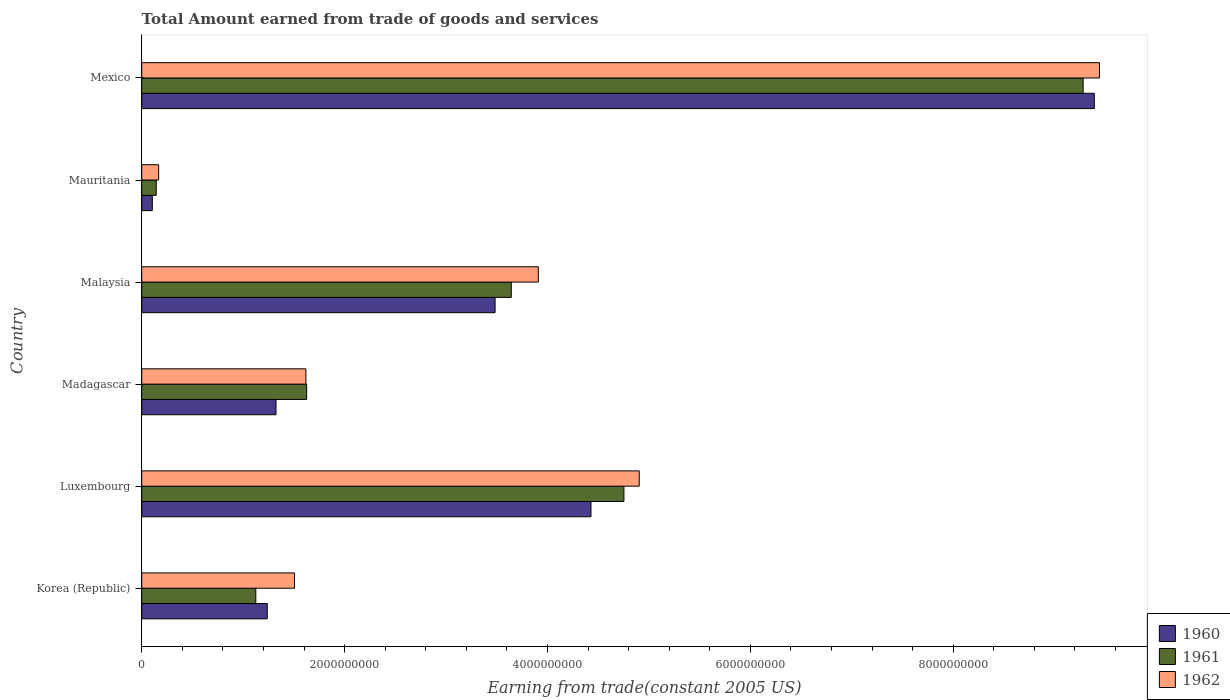Are the number of bars per tick equal to the number of legend labels?
Provide a short and direct response. Yes. How many bars are there on the 2nd tick from the bottom?
Make the answer very short. 3. What is the label of the 4th group of bars from the top?
Provide a succinct answer. Madagascar. What is the total amount earned by trading goods and services in 1962 in Malaysia?
Provide a succinct answer. 3.91e+09. Across all countries, what is the maximum total amount earned by trading goods and services in 1962?
Ensure brevity in your answer.  9.44e+09. Across all countries, what is the minimum total amount earned by trading goods and services in 1960?
Your answer should be very brief. 1.04e+08. In which country was the total amount earned by trading goods and services in 1961 maximum?
Offer a terse response. Mexico. In which country was the total amount earned by trading goods and services in 1960 minimum?
Make the answer very short. Mauritania. What is the total total amount earned by trading goods and services in 1960 in the graph?
Your answer should be compact. 2.00e+1. What is the difference between the total amount earned by trading goods and services in 1961 in Malaysia and that in Mexico?
Give a very brief answer. -5.64e+09. What is the difference between the total amount earned by trading goods and services in 1961 in Madagascar and the total amount earned by trading goods and services in 1962 in Korea (Republic)?
Your answer should be very brief. 1.20e+08. What is the average total amount earned by trading goods and services in 1962 per country?
Your response must be concise. 3.59e+09. What is the difference between the total amount earned by trading goods and services in 1961 and total amount earned by trading goods and services in 1962 in Madagascar?
Keep it short and to the point. 7.38e+06. What is the ratio of the total amount earned by trading goods and services in 1962 in Madagascar to that in Mauritania?
Make the answer very short. 9.69. Is the total amount earned by trading goods and services in 1962 in Korea (Republic) less than that in Madagascar?
Ensure brevity in your answer.  Yes. What is the difference between the highest and the second highest total amount earned by trading goods and services in 1962?
Make the answer very short. 4.54e+09. What is the difference between the highest and the lowest total amount earned by trading goods and services in 1960?
Your response must be concise. 9.29e+09. In how many countries, is the total amount earned by trading goods and services in 1962 greater than the average total amount earned by trading goods and services in 1962 taken over all countries?
Make the answer very short. 3. Is the sum of the total amount earned by trading goods and services in 1961 in Luxembourg and Madagascar greater than the maximum total amount earned by trading goods and services in 1962 across all countries?
Your answer should be compact. No. What does the 3rd bar from the bottom in Malaysia represents?
Ensure brevity in your answer.  1962. Is it the case that in every country, the sum of the total amount earned by trading goods and services in 1962 and total amount earned by trading goods and services in 1961 is greater than the total amount earned by trading goods and services in 1960?
Your response must be concise. Yes. Are all the bars in the graph horizontal?
Keep it short and to the point. Yes. How many countries are there in the graph?
Provide a short and direct response. 6. Are the values on the major ticks of X-axis written in scientific E-notation?
Offer a terse response. No. What is the title of the graph?
Keep it short and to the point. Total Amount earned from trade of goods and services. What is the label or title of the X-axis?
Offer a very short reply. Earning from trade(constant 2005 US). What is the label or title of the Y-axis?
Your response must be concise. Country. What is the Earning from trade(constant 2005 US) in 1960 in Korea (Republic)?
Offer a terse response. 1.24e+09. What is the Earning from trade(constant 2005 US) in 1961 in Korea (Republic)?
Give a very brief answer. 1.12e+09. What is the Earning from trade(constant 2005 US) of 1962 in Korea (Republic)?
Provide a short and direct response. 1.51e+09. What is the Earning from trade(constant 2005 US) of 1960 in Luxembourg?
Keep it short and to the point. 4.43e+09. What is the Earning from trade(constant 2005 US) in 1961 in Luxembourg?
Offer a very short reply. 4.75e+09. What is the Earning from trade(constant 2005 US) of 1962 in Luxembourg?
Provide a short and direct response. 4.90e+09. What is the Earning from trade(constant 2005 US) in 1960 in Madagascar?
Ensure brevity in your answer.  1.32e+09. What is the Earning from trade(constant 2005 US) in 1961 in Madagascar?
Keep it short and to the point. 1.63e+09. What is the Earning from trade(constant 2005 US) of 1962 in Madagascar?
Provide a succinct answer. 1.62e+09. What is the Earning from trade(constant 2005 US) of 1960 in Malaysia?
Offer a terse response. 3.48e+09. What is the Earning from trade(constant 2005 US) in 1961 in Malaysia?
Provide a succinct answer. 3.64e+09. What is the Earning from trade(constant 2005 US) of 1962 in Malaysia?
Your response must be concise. 3.91e+09. What is the Earning from trade(constant 2005 US) in 1960 in Mauritania?
Provide a succinct answer. 1.04e+08. What is the Earning from trade(constant 2005 US) of 1961 in Mauritania?
Provide a short and direct response. 1.43e+08. What is the Earning from trade(constant 2005 US) of 1962 in Mauritania?
Make the answer very short. 1.67e+08. What is the Earning from trade(constant 2005 US) of 1960 in Mexico?
Your answer should be compact. 9.39e+09. What is the Earning from trade(constant 2005 US) in 1961 in Mexico?
Provide a short and direct response. 9.28e+09. What is the Earning from trade(constant 2005 US) of 1962 in Mexico?
Your response must be concise. 9.44e+09. Across all countries, what is the maximum Earning from trade(constant 2005 US) of 1960?
Keep it short and to the point. 9.39e+09. Across all countries, what is the maximum Earning from trade(constant 2005 US) of 1961?
Keep it short and to the point. 9.28e+09. Across all countries, what is the maximum Earning from trade(constant 2005 US) in 1962?
Provide a succinct answer. 9.44e+09. Across all countries, what is the minimum Earning from trade(constant 2005 US) in 1960?
Offer a terse response. 1.04e+08. Across all countries, what is the minimum Earning from trade(constant 2005 US) in 1961?
Your answer should be very brief. 1.43e+08. Across all countries, what is the minimum Earning from trade(constant 2005 US) in 1962?
Your response must be concise. 1.67e+08. What is the total Earning from trade(constant 2005 US) in 1960 in the graph?
Offer a terse response. 2.00e+1. What is the total Earning from trade(constant 2005 US) of 1961 in the graph?
Your answer should be compact. 2.06e+1. What is the total Earning from trade(constant 2005 US) in 1962 in the graph?
Give a very brief answer. 2.15e+1. What is the difference between the Earning from trade(constant 2005 US) in 1960 in Korea (Republic) and that in Luxembourg?
Provide a short and direct response. -3.19e+09. What is the difference between the Earning from trade(constant 2005 US) in 1961 in Korea (Republic) and that in Luxembourg?
Offer a terse response. -3.63e+09. What is the difference between the Earning from trade(constant 2005 US) of 1962 in Korea (Republic) and that in Luxembourg?
Offer a very short reply. -3.40e+09. What is the difference between the Earning from trade(constant 2005 US) of 1960 in Korea (Republic) and that in Madagascar?
Make the answer very short. -8.60e+07. What is the difference between the Earning from trade(constant 2005 US) of 1961 in Korea (Republic) and that in Madagascar?
Your answer should be compact. -5.02e+08. What is the difference between the Earning from trade(constant 2005 US) in 1962 in Korea (Republic) and that in Madagascar?
Give a very brief answer. -1.12e+08. What is the difference between the Earning from trade(constant 2005 US) of 1960 in Korea (Republic) and that in Malaysia?
Your answer should be very brief. -2.25e+09. What is the difference between the Earning from trade(constant 2005 US) of 1961 in Korea (Republic) and that in Malaysia?
Keep it short and to the point. -2.52e+09. What is the difference between the Earning from trade(constant 2005 US) of 1962 in Korea (Republic) and that in Malaysia?
Offer a terse response. -2.40e+09. What is the difference between the Earning from trade(constant 2005 US) in 1960 in Korea (Republic) and that in Mauritania?
Provide a short and direct response. 1.13e+09. What is the difference between the Earning from trade(constant 2005 US) of 1961 in Korea (Republic) and that in Mauritania?
Keep it short and to the point. 9.82e+08. What is the difference between the Earning from trade(constant 2005 US) in 1962 in Korea (Republic) and that in Mauritania?
Make the answer very short. 1.34e+09. What is the difference between the Earning from trade(constant 2005 US) in 1960 in Korea (Republic) and that in Mexico?
Keep it short and to the point. -8.15e+09. What is the difference between the Earning from trade(constant 2005 US) in 1961 in Korea (Republic) and that in Mexico?
Give a very brief answer. -8.16e+09. What is the difference between the Earning from trade(constant 2005 US) of 1962 in Korea (Republic) and that in Mexico?
Give a very brief answer. -7.94e+09. What is the difference between the Earning from trade(constant 2005 US) of 1960 in Luxembourg and that in Madagascar?
Ensure brevity in your answer.  3.11e+09. What is the difference between the Earning from trade(constant 2005 US) in 1961 in Luxembourg and that in Madagascar?
Ensure brevity in your answer.  3.13e+09. What is the difference between the Earning from trade(constant 2005 US) of 1962 in Luxembourg and that in Madagascar?
Provide a succinct answer. 3.29e+09. What is the difference between the Earning from trade(constant 2005 US) of 1960 in Luxembourg and that in Malaysia?
Offer a terse response. 9.45e+08. What is the difference between the Earning from trade(constant 2005 US) of 1961 in Luxembourg and that in Malaysia?
Keep it short and to the point. 1.11e+09. What is the difference between the Earning from trade(constant 2005 US) in 1962 in Luxembourg and that in Malaysia?
Your answer should be compact. 9.95e+08. What is the difference between the Earning from trade(constant 2005 US) of 1960 in Luxembourg and that in Mauritania?
Make the answer very short. 4.32e+09. What is the difference between the Earning from trade(constant 2005 US) of 1961 in Luxembourg and that in Mauritania?
Make the answer very short. 4.61e+09. What is the difference between the Earning from trade(constant 2005 US) in 1962 in Luxembourg and that in Mauritania?
Offer a terse response. 4.74e+09. What is the difference between the Earning from trade(constant 2005 US) of 1960 in Luxembourg and that in Mexico?
Offer a terse response. -4.96e+09. What is the difference between the Earning from trade(constant 2005 US) in 1961 in Luxembourg and that in Mexico?
Provide a short and direct response. -4.53e+09. What is the difference between the Earning from trade(constant 2005 US) of 1962 in Luxembourg and that in Mexico?
Your answer should be compact. -4.54e+09. What is the difference between the Earning from trade(constant 2005 US) of 1960 in Madagascar and that in Malaysia?
Your response must be concise. -2.16e+09. What is the difference between the Earning from trade(constant 2005 US) of 1961 in Madagascar and that in Malaysia?
Give a very brief answer. -2.02e+09. What is the difference between the Earning from trade(constant 2005 US) in 1962 in Madagascar and that in Malaysia?
Your answer should be compact. -2.29e+09. What is the difference between the Earning from trade(constant 2005 US) in 1960 in Madagascar and that in Mauritania?
Offer a terse response. 1.22e+09. What is the difference between the Earning from trade(constant 2005 US) in 1961 in Madagascar and that in Mauritania?
Give a very brief answer. 1.48e+09. What is the difference between the Earning from trade(constant 2005 US) in 1962 in Madagascar and that in Mauritania?
Your answer should be compact. 1.45e+09. What is the difference between the Earning from trade(constant 2005 US) of 1960 in Madagascar and that in Mexico?
Keep it short and to the point. -8.07e+09. What is the difference between the Earning from trade(constant 2005 US) in 1961 in Madagascar and that in Mexico?
Make the answer very short. -7.65e+09. What is the difference between the Earning from trade(constant 2005 US) of 1962 in Madagascar and that in Mexico?
Your answer should be compact. -7.82e+09. What is the difference between the Earning from trade(constant 2005 US) of 1960 in Malaysia and that in Mauritania?
Provide a succinct answer. 3.38e+09. What is the difference between the Earning from trade(constant 2005 US) in 1961 in Malaysia and that in Mauritania?
Your response must be concise. 3.50e+09. What is the difference between the Earning from trade(constant 2005 US) in 1962 in Malaysia and that in Mauritania?
Your answer should be very brief. 3.74e+09. What is the difference between the Earning from trade(constant 2005 US) of 1960 in Malaysia and that in Mexico?
Provide a short and direct response. -5.91e+09. What is the difference between the Earning from trade(constant 2005 US) of 1961 in Malaysia and that in Mexico?
Make the answer very short. -5.64e+09. What is the difference between the Earning from trade(constant 2005 US) of 1962 in Malaysia and that in Mexico?
Your answer should be compact. -5.53e+09. What is the difference between the Earning from trade(constant 2005 US) of 1960 in Mauritania and that in Mexico?
Offer a terse response. -9.29e+09. What is the difference between the Earning from trade(constant 2005 US) in 1961 in Mauritania and that in Mexico?
Offer a very short reply. -9.14e+09. What is the difference between the Earning from trade(constant 2005 US) in 1962 in Mauritania and that in Mexico?
Your answer should be compact. -9.28e+09. What is the difference between the Earning from trade(constant 2005 US) of 1960 in Korea (Republic) and the Earning from trade(constant 2005 US) of 1961 in Luxembourg?
Your answer should be compact. -3.52e+09. What is the difference between the Earning from trade(constant 2005 US) in 1960 in Korea (Republic) and the Earning from trade(constant 2005 US) in 1962 in Luxembourg?
Your response must be concise. -3.67e+09. What is the difference between the Earning from trade(constant 2005 US) in 1961 in Korea (Republic) and the Earning from trade(constant 2005 US) in 1962 in Luxembourg?
Offer a very short reply. -3.78e+09. What is the difference between the Earning from trade(constant 2005 US) in 1960 in Korea (Republic) and the Earning from trade(constant 2005 US) in 1961 in Madagascar?
Your response must be concise. -3.88e+08. What is the difference between the Earning from trade(constant 2005 US) in 1960 in Korea (Republic) and the Earning from trade(constant 2005 US) in 1962 in Madagascar?
Offer a very short reply. -3.81e+08. What is the difference between the Earning from trade(constant 2005 US) in 1961 in Korea (Republic) and the Earning from trade(constant 2005 US) in 1962 in Madagascar?
Your answer should be compact. -4.94e+08. What is the difference between the Earning from trade(constant 2005 US) in 1960 in Korea (Republic) and the Earning from trade(constant 2005 US) in 1961 in Malaysia?
Your answer should be very brief. -2.41e+09. What is the difference between the Earning from trade(constant 2005 US) of 1960 in Korea (Republic) and the Earning from trade(constant 2005 US) of 1962 in Malaysia?
Offer a very short reply. -2.67e+09. What is the difference between the Earning from trade(constant 2005 US) of 1961 in Korea (Republic) and the Earning from trade(constant 2005 US) of 1962 in Malaysia?
Provide a succinct answer. -2.79e+09. What is the difference between the Earning from trade(constant 2005 US) in 1960 in Korea (Republic) and the Earning from trade(constant 2005 US) in 1961 in Mauritania?
Keep it short and to the point. 1.09e+09. What is the difference between the Earning from trade(constant 2005 US) in 1960 in Korea (Republic) and the Earning from trade(constant 2005 US) in 1962 in Mauritania?
Provide a succinct answer. 1.07e+09. What is the difference between the Earning from trade(constant 2005 US) of 1961 in Korea (Republic) and the Earning from trade(constant 2005 US) of 1962 in Mauritania?
Provide a short and direct response. 9.58e+08. What is the difference between the Earning from trade(constant 2005 US) in 1960 in Korea (Republic) and the Earning from trade(constant 2005 US) in 1961 in Mexico?
Provide a succinct answer. -8.04e+09. What is the difference between the Earning from trade(constant 2005 US) in 1960 in Korea (Republic) and the Earning from trade(constant 2005 US) in 1962 in Mexico?
Provide a succinct answer. -8.20e+09. What is the difference between the Earning from trade(constant 2005 US) of 1961 in Korea (Republic) and the Earning from trade(constant 2005 US) of 1962 in Mexico?
Offer a very short reply. -8.32e+09. What is the difference between the Earning from trade(constant 2005 US) of 1960 in Luxembourg and the Earning from trade(constant 2005 US) of 1961 in Madagascar?
Keep it short and to the point. 2.80e+09. What is the difference between the Earning from trade(constant 2005 US) in 1960 in Luxembourg and the Earning from trade(constant 2005 US) in 1962 in Madagascar?
Make the answer very short. 2.81e+09. What is the difference between the Earning from trade(constant 2005 US) in 1961 in Luxembourg and the Earning from trade(constant 2005 US) in 1962 in Madagascar?
Give a very brief answer. 3.14e+09. What is the difference between the Earning from trade(constant 2005 US) in 1960 in Luxembourg and the Earning from trade(constant 2005 US) in 1961 in Malaysia?
Make the answer very short. 7.86e+08. What is the difference between the Earning from trade(constant 2005 US) in 1960 in Luxembourg and the Earning from trade(constant 2005 US) in 1962 in Malaysia?
Give a very brief answer. 5.19e+08. What is the difference between the Earning from trade(constant 2005 US) in 1961 in Luxembourg and the Earning from trade(constant 2005 US) in 1962 in Malaysia?
Your answer should be very brief. 8.44e+08. What is the difference between the Earning from trade(constant 2005 US) in 1960 in Luxembourg and the Earning from trade(constant 2005 US) in 1961 in Mauritania?
Provide a succinct answer. 4.29e+09. What is the difference between the Earning from trade(constant 2005 US) in 1960 in Luxembourg and the Earning from trade(constant 2005 US) in 1962 in Mauritania?
Offer a terse response. 4.26e+09. What is the difference between the Earning from trade(constant 2005 US) in 1961 in Luxembourg and the Earning from trade(constant 2005 US) in 1962 in Mauritania?
Your response must be concise. 4.59e+09. What is the difference between the Earning from trade(constant 2005 US) in 1960 in Luxembourg and the Earning from trade(constant 2005 US) in 1961 in Mexico?
Offer a very short reply. -4.85e+09. What is the difference between the Earning from trade(constant 2005 US) in 1960 in Luxembourg and the Earning from trade(constant 2005 US) in 1962 in Mexico?
Make the answer very short. -5.01e+09. What is the difference between the Earning from trade(constant 2005 US) in 1961 in Luxembourg and the Earning from trade(constant 2005 US) in 1962 in Mexico?
Provide a short and direct response. -4.69e+09. What is the difference between the Earning from trade(constant 2005 US) in 1960 in Madagascar and the Earning from trade(constant 2005 US) in 1961 in Malaysia?
Offer a very short reply. -2.32e+09. What is the difference between the Earning from trade(constant 2005 US) of 1960 in Madagascar and the Earning from trade(constant 2005 US) of 1962 in Malaysia?
Give a very brief answer. -2.59e+09. What is the difference between the Earning from trade(constant 2005 US) of 1961 in Madagascar and the Earning from trade(constant 2005 US) of 1962 in Malaysia?
Keep it short and to the point. -2.28e+09. What is the difference between the Earning from trade(constant 2005 US) of 1960 in Madagascar and the Earning from trade(constant 2005 US) of 1961 in Mauritania?
Provide a succinct answer. 1.18e+09. What is the difference between the Earning from trade(constant 2005 US) in 1960 in Madagascar and the Earning from trade(constant 2005 US) in 1962 in Mauritania?
Your answer should be compact. 1.16e+09. What is the difference between the Earning from trade(constant 2005 US) of 1961 in Madagascar and the Earning from trade(constant 2005 US) of 1962 in Mauritania?
Your response must be concise. 1.46e+09. What is the difference between the Earning from trade(constant 2005 US) in 1960 in Madagascar and the Earning from trade(constant 2005 US) in 1961 in Mexico?
Your response must be concise. -7.96e+09. What is the difference between the Earning from trade(constant 2005 US) of 1960 in Madagascar and the Earning from trade(constant 2005 US) of 1962 in Mexico?
Your answer should be very brief. -8.12e+09. What is the difference between the Earning from trade(constant 2005 US) in 1961 in Madagascar and the Earning from trade(constant 2005 US) in 1962 in Mexico?
Your answer should be very brief. -7.82e+09. What is the difference between the Earning from trade(constant 2005 US) in 1960 in Malaysia and the Earning from trade(constant 2005 US) in 1961 in Mauritania?
Provide a succinct answer. 3.34e+09. What is the difference between the Earning from trade(constant 2005 US) of 1960 in Malaysia and the Earning from trade(constant 2005 US) of 1962 in Mauritania?
Keep it short and to the point. 3.32e+09. What is the difference between the Earning from trade(constant 2005 US) of 1961 in Malaysia and the Earning from trade(constant 2005 US) of 1962 in Mauritania?
Offer a terse response. 3.48e+09. What is the difference between the Earning from trade(constant 2005 US) in 1960 in Malaysia and the Earning from trade(constant 2005 US) in 1961 in Mexico?
Your answer should be very brief. -5.80e+09. What is the difference between the Earning from trade(constant 2005 US) of 1960 in Malaysia and the Earning from trade(constant 2005 US) of 1962 in Mexico?
Offer a very short reply. -5.96e+09. What is the difference between the Earning from trade(constant 2005 US) of 1961 in Malaysia and the Earning from trade(constant 2005 US) of 1962 in Mexico?
Make the answer very short. -5.80e+09. What is the difference between the Earning from trade(constant 2005 US) of 1960 in Mauritania and the Earning from trade(constant 2005 US) of 1961 in Mexico?
Keep it short and to the point. -9.18e+09. What is the difference between the Earning from trade(constant 2005 US) in 1960 in Mauritania and the Earning from trade(constant 2005 US) in 1962 in Mexico?
Provide a short and direct response. -9.34e+09. What is the difference between the Earning from trade(constant 2005 US) in 1961 in Mauritania and the Earning from trade(constant 2005 US) in 1962 in Mexico?
Provide a short and direct response. -9.30e+09. What is the average Earning from trade(constant 2005 US) of 1960 per country?
Ensure brevity in your answer.  3.33e+09. What is the average Earning from trade(constant 2005 US) in 1961 per country?
Make the answer very short. 3.43e+09. What is the average Earning from trade(constant 2005 US) in 1962 per country?
Keep it short and to the point. 3.59e+09. What is the difference between the Earning from trade(constant 2005 US) in 1960 and Earning from trade(constant 2005 US) in 1961 in Korea (Republic)?
Provide a succinct answer. 1.13e+08. What is the difference between the Earning from trade(constant 2005 US) in 1960 and Earning from trade(constant 2005 US) in 1962 in Korea (Republic)?
Offer a very short reply. -2.69e+08. What is the difference between the Earning from trade(constant 2005 US) in 1961 and Earning from trade(constant 2005 US) in 1962 in Korea (Republic)?
Ensure brevity in your answer.  -3.82e+08. What is the difference between the Earning from trade(constant 2005 US) in 1960 and Earning from trade(constant 2005 US) in 1961 in Luxembourg?
Offer a terse response. -3.25e+08. What is the difference between the Earning from trade(constant 2005 US) in 1960 and Earning from trade(constant 2005 US) in 1962 in Luxembourg?
Your response must be concise. -4.76e+08. What is the difference between the Earning from trade(constant 2005 US) in 1961 and Earning from trade(constant 2005 US) in 1962 in Luxembourg?
Your answer should be very brief. -1.51e+08. What is the difference between the Earning from trade(constant 2005 US) of 1960 and Earning from trade(constant 2005 US) of 1961 in Madagascar?
Your response must be concise. -3.02e+08. What is the difference between the Earning from trade(constant 2005 US) in 1960 and Earning from trade(constant 2005 US) in 1962 in Madagascar?
Ensure brevity in your answer.  -2.95e+08. What is the difference between the Earning from trade(constant 2005 US) of 1961 and Earning from trade(constant 2005 US) of 1962 in Madagascar?
Keep it short and to the point. 7.38e+06. What is the difference between the Earning from trade(constant 2005 US) of 1960 and Earning from trade(constant 2005 US) of 1961 in Malaysia?
Provide a short and direct response. -1.60e+08. What is the difference between the Earning from trade(constant 2005 US) in 1960 and Earning from trade(constant 2005 US) in 1962 in Malaysia?
Your response must be concise. -4.26e+08. What is the difference between the Earning from trade(constant 2005 US) of 1961 and Earning from trade(constant 2005 US) of 1962 in Malaysia?
Make the answer very short. -2.67e+08. What is the difference between the Earning from trade(constant 2005 US) in 1960 and Earning from trade(constant 2005 US) in 1961 in Mauritania?
Ensure brevity in your answer.  -3.85e+07. What is the difference between the Earning from trade(constant 2005 US) in 1960 and Earning from trade(constant 2005 US) in 1962 in Mauritania?
Make the answer very short. -6.27e+07. What is the difference between the Earning from trade(constant 2005 US) of 1961 and Earning from trade(constant 2005 US) of 1962 in Mauritania?
Keep it short and to the point. -2.42e+07. What is the difference between the Earning from trade(constant 2005 US) in 1960 and Earning from trade(constant 2005 US) in 1961 in Mexico?
Offer a very short reply. 1.10e+08. What is the difference between the Earning from trade(constant 2005 US) of 1960 and Earning from trade(constant 2005 US) of 1962 in Mexico?
Offer a terse response. -5.10e+07. What is the difference between the Earning from trade(constant 2005 US) of 1961 and Earning from trade(constant 2005 US) of 1962 in Mexico?
Provide a succinct answer. -1.61e+08. What is the ratio of the Earning from trade(constant 2005 US) in 1960 in Korea (Republic) to that in Luxembourg?
Make the answer very short. 0.28. What is the ratio of the Earning from trade(constant 2005 US) in 1961 in Korea (Republic) to that in Luxembourg?
Give a very brief answer. 0.24. What is the ratio of the Earning from trade(constant 2005 US) of 1962 in Korea (Republic) to that in Luxembourg?
Your answer should be very brief. 0.31. What is the ratio of the Earning from trade(constant 2005 US) of 1960 in Korea (Republic) to that in Madagascar?
Your response must be concise. 0.94. What is the ratio of the Earning from trade(constant 2005 US) of 1961 in Korea (Republic) to that in Madagascar?
Offer a very short reply. 0.69. What is the ratio of the Earning from trade(constant 2005 US) of 1962 in Korea (Republic) to that in Madagascar?
Give a very brief answer. 0.93. What is the ratio of the Earning from trade(constant 2005 US) in 1960 in Korea (Republic) to that in Malaysia?
Keep it short and to the point. 0.36. What is the ratio of the Earning from trade(constant 2005 US) of 1961 in Korea (Republic) to that in Malaysia?
Offer a very short reply. 0.31. What is the ratio of the Earning from trade(constant 2005 US) of 1962 in Korea (Republic) to that in Malaysia?
Offer a terse response. 0.39. What is the ratio of the Earning from trade(constant 2005 US) of 1960 in Korea (Republic) to that in Mauritania?
Provide a succinct answer. 11.86. What is the ratio of the Earning from trade(constant 2005 US) in 1961 in Korea (Republic) to that in Mauritania?
Your response must be concise. 7.87. What is the ratio of the Earning from trade(constant 2005 US) in 1962 in Korea (Republic) to that in Mauritania?
Your answer should be compact. 9.02. What is the ratio of the Earning from trade(constant 2005 US) in 1960 in Korea (Republic) to that in Mexico?
Your answer should be compact. 0.13. What is the ratio of the Earning from trade(constant 2005 US) of 1961 in Korea (Republic) to that in Mexico?
Make the answer very short. 0.12. What is the ratio of the Earning from trade(constant 2005 US) in 1962 in Korea (Republic) to that in Mexico?
Your answer should be compact. 0.16. What is the ratio of the Earning from trade(constant 2005 US) in 1960 in Luxembourg to that in Madagascar?
Your response must be concise. 3.35. What is the ratio of the Earning from trade(constant 2005 US) in 1961 in Luxembourg to that in Madagascar?
Provide a succinct answer. 2.92. What is the ratio of the Earning from trade(constant 2005 US) of 1962 in Luxembourg to that in Madagascar?
Offer a terse response. 3.03. What is the ratio of the Earning from trade(constant 2005 US) in 1960 in Luxembourg to that in Malaysia?
Ensure brevity in your answer.  1.27. What is the ratio of the Earning from trade(constant 2005 US) in 1961 in Luxembourg to that in Malaysia?
Ensure brevity in your answer.  1.3. What is the ratio of the Earning from trade(constant 2005 US) in 1962 in Luxembourg to that in Malaysia?
Offer a very short reply. 1.25. What is the ratio of the Earning from trade(constant 2005 US) of 1960 in Luxembourg to that in Mauritania?
Keep it short and to the point. 42.45. What is the ratio of the Earning from trade(constant 2005 US) in 1961 in Luxembourg to that in Mauritania?
Make the answer very short. 33.28. What is the ratio of the Earning from trade(constant 2005 US) of 1962 in Luxembourg to that in Mauritania?
Make the answer very short. 29.37. What is the ratio of the Earning from trade(constant 2005 US) in 1960 in Luxembourg to that in Mexico?
Your answer should be very brief. 0.47. What is the ratio of the Earning from trade(constant 2005 US) in 1961 in Luxembourg to that in Mexico?
Offer a terse response. 0.51. What is the ratio of the Earning from trade(constant 2005 US) in 1962 in Luxembourg to that in Mexico?
Provide a short and direct response. 0.52. What is the ratio of the Earning from trade(constant 2005 US) in 1960 in Madagascar to that in Malaysia?
Give a very brief answer. 0.38. What is the ratio of the Earning from trade(constant 2005 US) in 1961 in Madagascar to that in Malaysia?
Make the answer very short. 0.45. What is the ratio of the Earning from trade(constant 2005 US) in 1962 in Madagascar to that in Malaysia?
Your answer should be very brief. 0.41. What is the ratio of the Earning from trade(constant 2005 US) in 1960 in Madagascar to that in Mauritania?
Offer a very short reply. 12.69. What is the ratio of the Earning from trade(constant 2005 US) of 1961 in Madagascar to that in Mauritania?
Your answer should be compact. 11.38. What is the ratio of the Earning from trade(constant 2005 US) of 1962 in Madagascar to that in Mauritania?
Your response must be concise. 9.69. What is the ratio of the Earning from trade(constant 2005 US) in 1960 in Madagascar to that in Mexico?
Make the answer very short. 0.14. What is the ratio of the Earning from trade(constant 2005 US) of 1961 in Madagascar to that in Mexico?
Offer a terse response. 0.18. What is the ratio of the Earning from trade(constant 2005 US) of 1962 in Madagascar to that in Mexico?
Your response must be concise. 0.17. What is the ratio of the Earning from trade(constant 2005 US) in 1960 in Malaysia to that in Mauritania?
Offer a terse response. 33.39. What is the ratio of the Earning from trade(constant 2005 US) of 1961 in Malaysia to that in Mauritania?
Your response must be concise. 25.51. What is the ratio of the Earning from trade(constant 2005 US) in 1962 in Malaysia to that in Mauritania?
Make the answer very short. 23.41. What is the ratio of the Earning from trade(constant 2005 US) of 1960 in Malaysia to that in Mexico?
Provide a short and direct response. 0.37. What is the ratio of the Earning from trade(constant 2005 US) of 1961 in Malaysia to that in Mexico?
Give a very brief answer. 0.39. What is the ratio of the Earning from trade(constant 2005 US) in 1962 in Malaysia to that in Mexico?
Your answer should be very brief. 0.41. What is the ratio of the Earning from trade(constant 2005 US) of 1960 in Mauritania to that in Mexico?
Provide a succinct answer. 0.01. What is the ratio of the Earning from trade(constant 2005 US) in 1961 in Mauritania to that in Mexico?
Provide a succinct answer. 0.02. What is the ratio of the Earning from trade(constant 2005 US) of 1962 in Mauritania to that in Mexico?
Give a very brief answer. 0.02. What is the difference between the highest and the second highest Earning from trade(constant 2005 US) in 1960?
Offer a terse response. 4.96e+09. What is the difference between the highest and the second highest Earning from trade(constant 2005 US) in 1961?
Your answer should be compact. 4.53e+09. What is the difference between the highest and the second highest Earning from trade(constant 2005 US) of 1962?
Offer a terse response. 4.54e+09. What is the difference between the highest and the lowest Earning from trade(constant 2005 US) of 1960?
Your response must be concise. 9.29e+09. What is the difference between the highest and the lowest Earning from trade(constant 2005 US) in 1961?
Offer a terse response. 9.14e+09. What is the difference between the highest and the lowest Earning from trade(constant 2005 US) in 1962?
Your answer should be compact. 9.28e+09. 